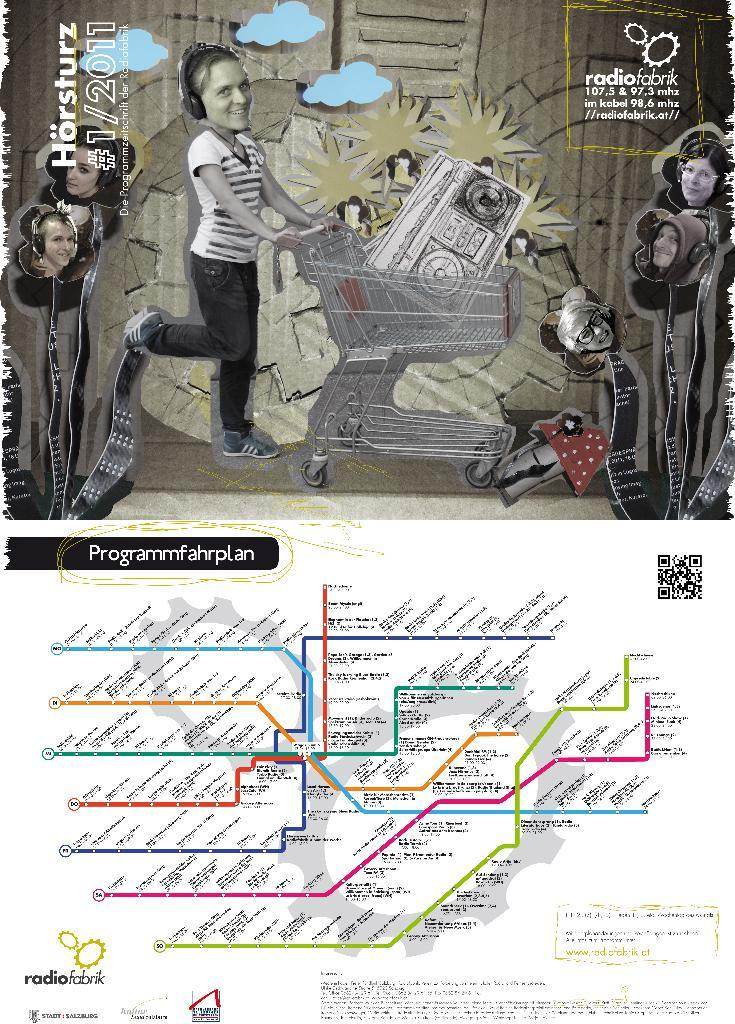What can be seen in the image that represents human figures? There are depictions of people in the image. What type of written information is present in the image? There is text in the image. Are there any numerical values visible in the image? Yes, there are numbers in the image. What other objects or elements can be seen in the image besides the people, text, and numbers? There are other objects in the image. How many legs can be seen on the card in the image? There is no card present in the image, and therefore no legs can be counted on a card. 